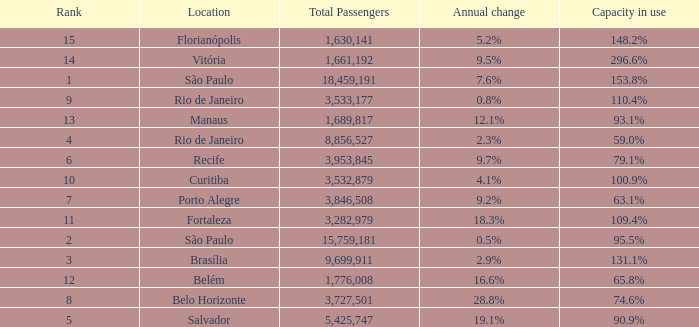What is the highest Total Passengers when the annual change is 18.3%, and the rank is less than 11? None. 